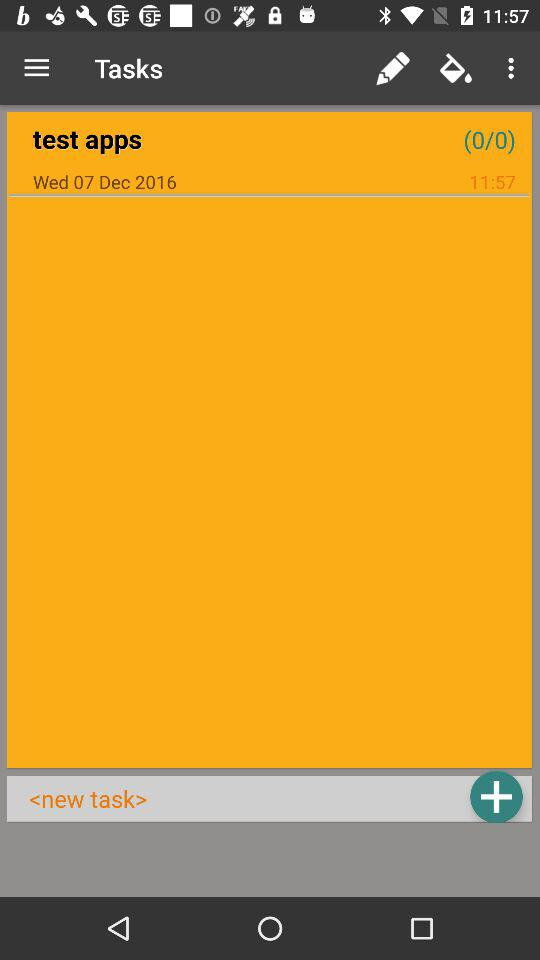Is there any tasks?
When the provided information is insufficient, respond with <no answer>. <no answer> 